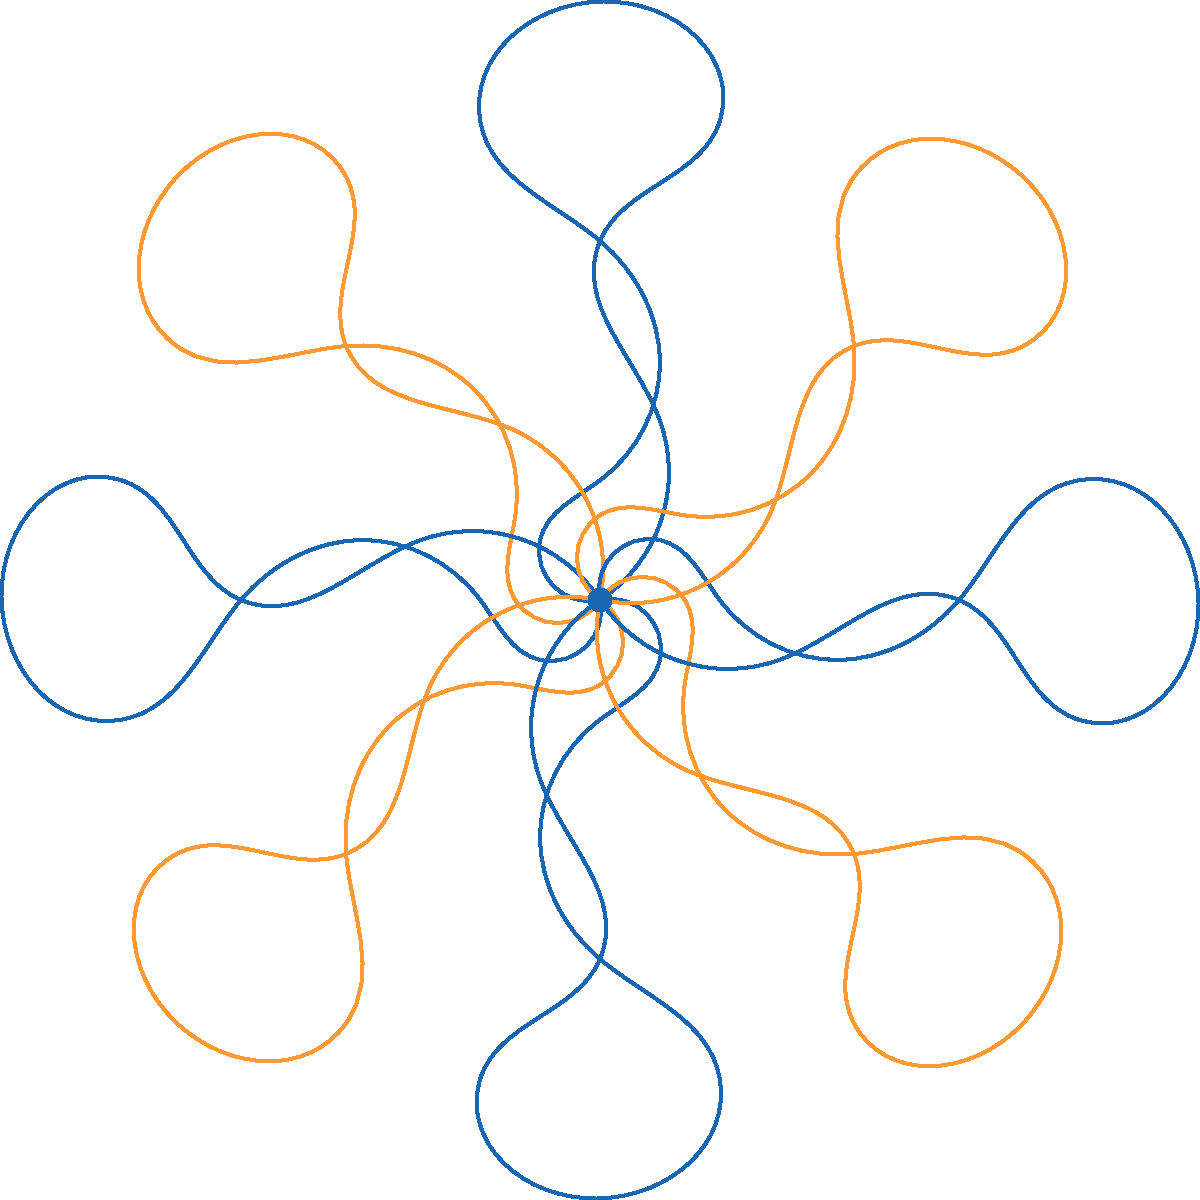In the jazzy pattern above, a treble clef symbol is rotated around a fixed point to create a symmetrical design. If the angle of rotation between each successive treble clef is 45°, how many complete rotations (in degrees) are needed to return the treble clef to its original position? To solve this problem, let's follow these steps:

1. Observe that the pattern consists of 8 treble clef symbols arranged in a circular pattern.

2. We're given that the angle of rotation between each successive treble clef is 45°.

3. To calculate the total rotation, we multiply the number of steps by the angle of each step:
   $8 \times 45° = 360°$

4. This means that after 8 rotations of 45°, the treble clef returns to its original position.

5. In geometry, a complete rotation is defined as 360°.

Therefore, the treble clef makes exactly one complete rotation (360°) to return to its original position.
Answer: 360° 